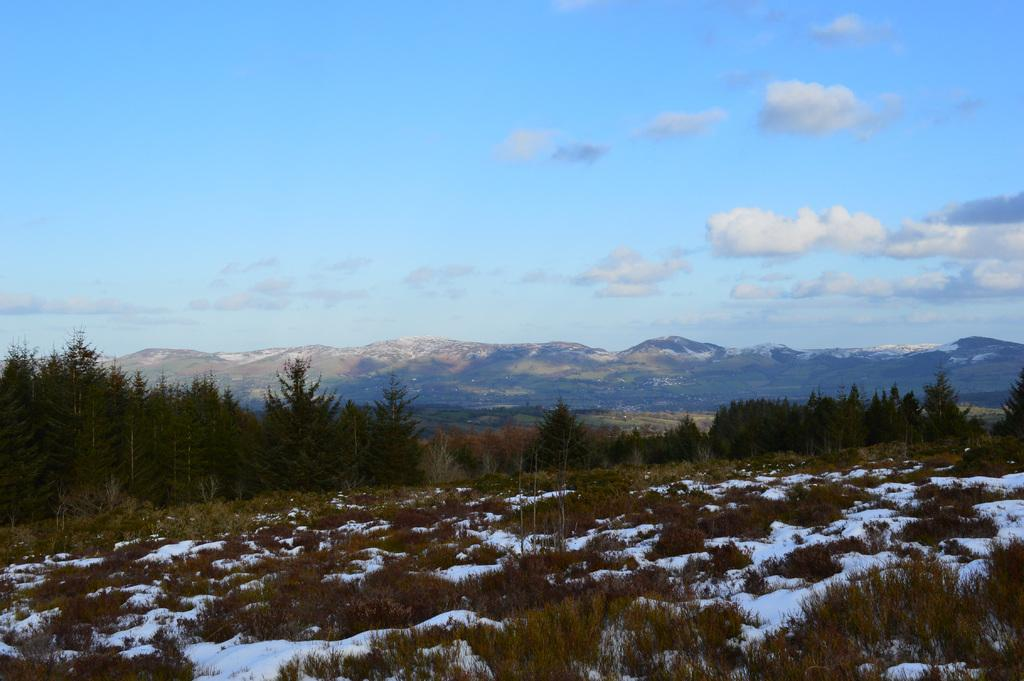What type of weather condition is depicted in the image? There is snow in the image, indicating a cold or wintry weather condition. What natural elements can be seen in the image? There are trees and mountains visible in the image. What is visible in the background of the image? The sky is visible in the background of the image. What can be observed in the sky? Clouds are present in the sky. Can you see a snake slithering through the snow in the image? No, there is no snake present in the image. How many feet of snow can be seen in the image? The amount of snow cannot be determined from the image alone, as it only shows the presence of snow without specifying its depth. 